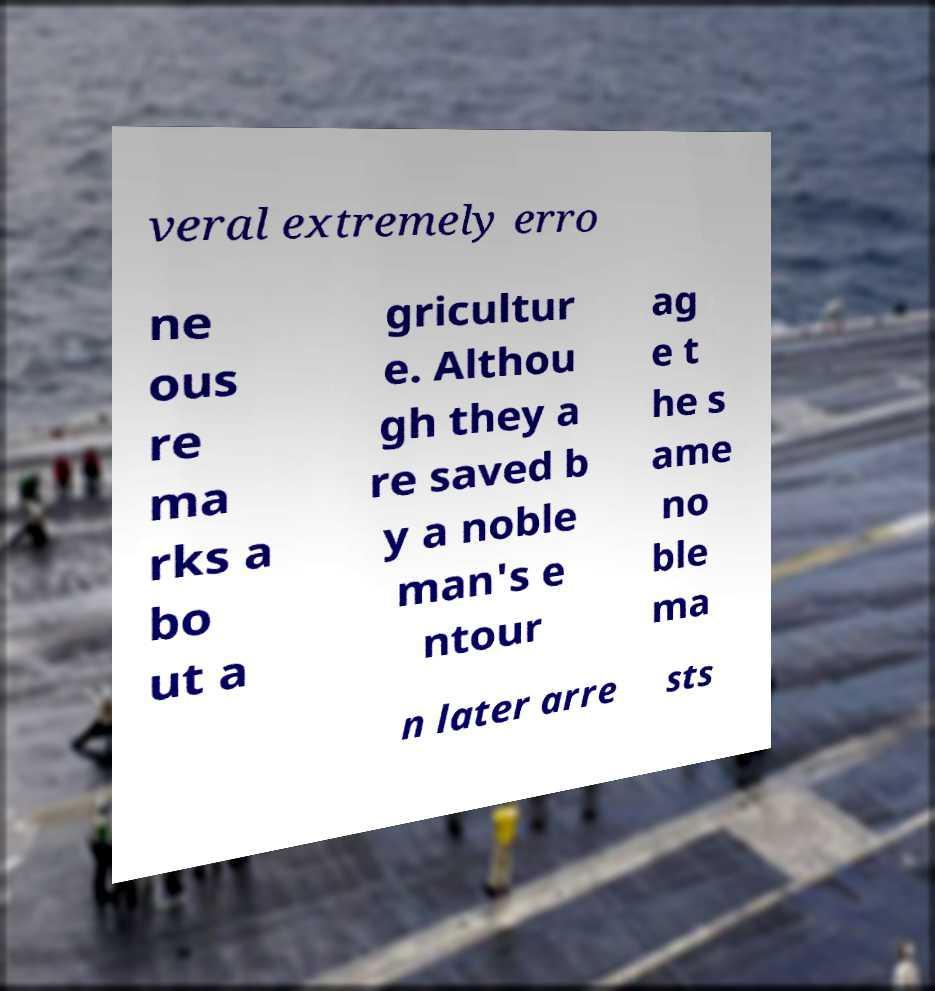Please read and relay the text visible in this image. What does it say? veral extremely erro ne ous re ma rks a bo ut a gricultur e. Althou gh they a re saved b y a noble man's e ntour ag e t he s ame no ble ma n later arre sts 